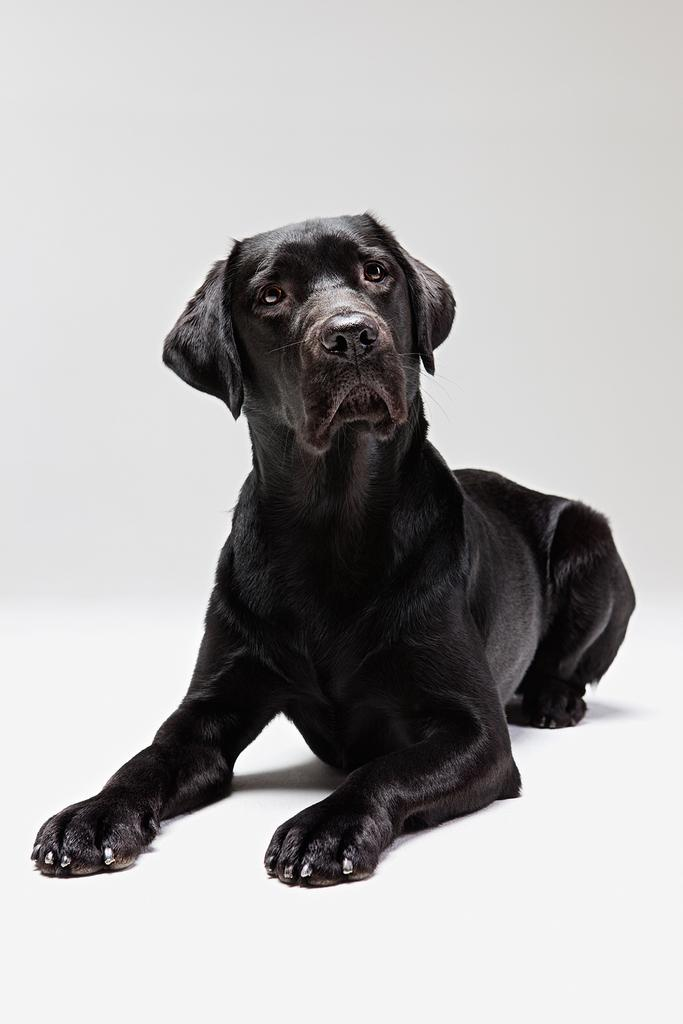What type of animal is in the image? There is a black dog in the image. What color is the background of the image? The background of the image is white. How many friends does the flower have in the image? There is no flower present in the image, so it is not possible to determine how many friends it might have. 